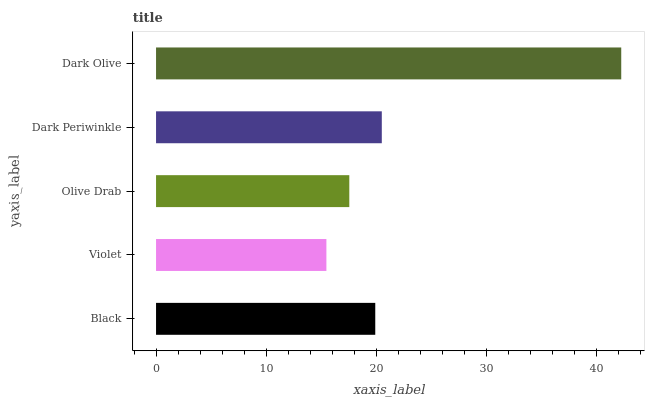Is Violet the minimum?
Answer yes or no. Yes. Is Dark Olive the maximum?
Answer yes or no. Yes. Is Olive Drab the minimum?
Answer yes or no. No. Is Olive Drab the maximum?
Answer yes or no. No. Is Olive Drab greater than Violet?
Answer yes or no. Yes. Is Violet less than Olive Drab?
Answer yes or no. Yes. Is Violet greater than Olive Drab?
Answer yes or no. No. Is Olive Drab less than Violet?
Answer yes or no. No. Is Black the high median?
Answer yes or no. Yes. Is Black the low median?
Answer yes or no. Yes. Is Olive Drab the high median?
Answer yes or no. No. Is Violet the low median?
Answer yes or no. No. 